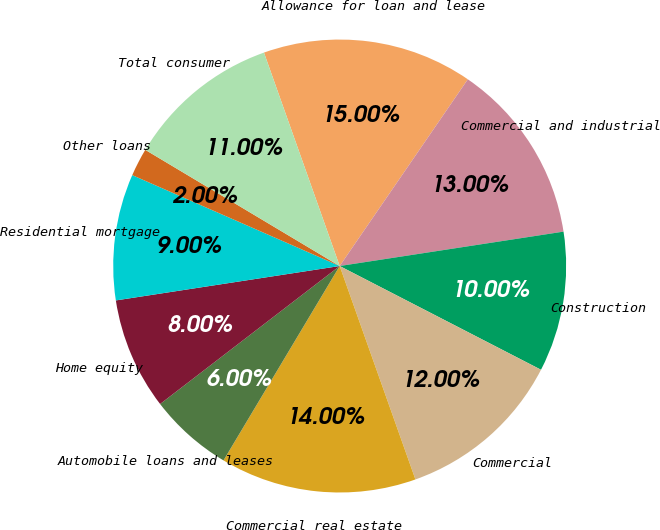Convert chart. <chart><loc_0><loc_0><loc_500><loc_500><pie_chart><fcel>Allowance for loan and lease<fcel>Commercial and industrial<fcel>Construction<fcel>Commercial<fcel>Commercial real estate<fcel>Automobile loans and leases<fcel>Home equity<fcel>Residential mortgage<fcel>Other loans<fcel>Total consumer<nl><fcel>15.0%<fcel>13.0%<fcel>10.0%<fcel>12.0%<fcel>14.0%<fcel>6.0%<fcel>8.0%<fcel>9.0%<fcel>2.0%<fcel>11.0%<nl></chart> 